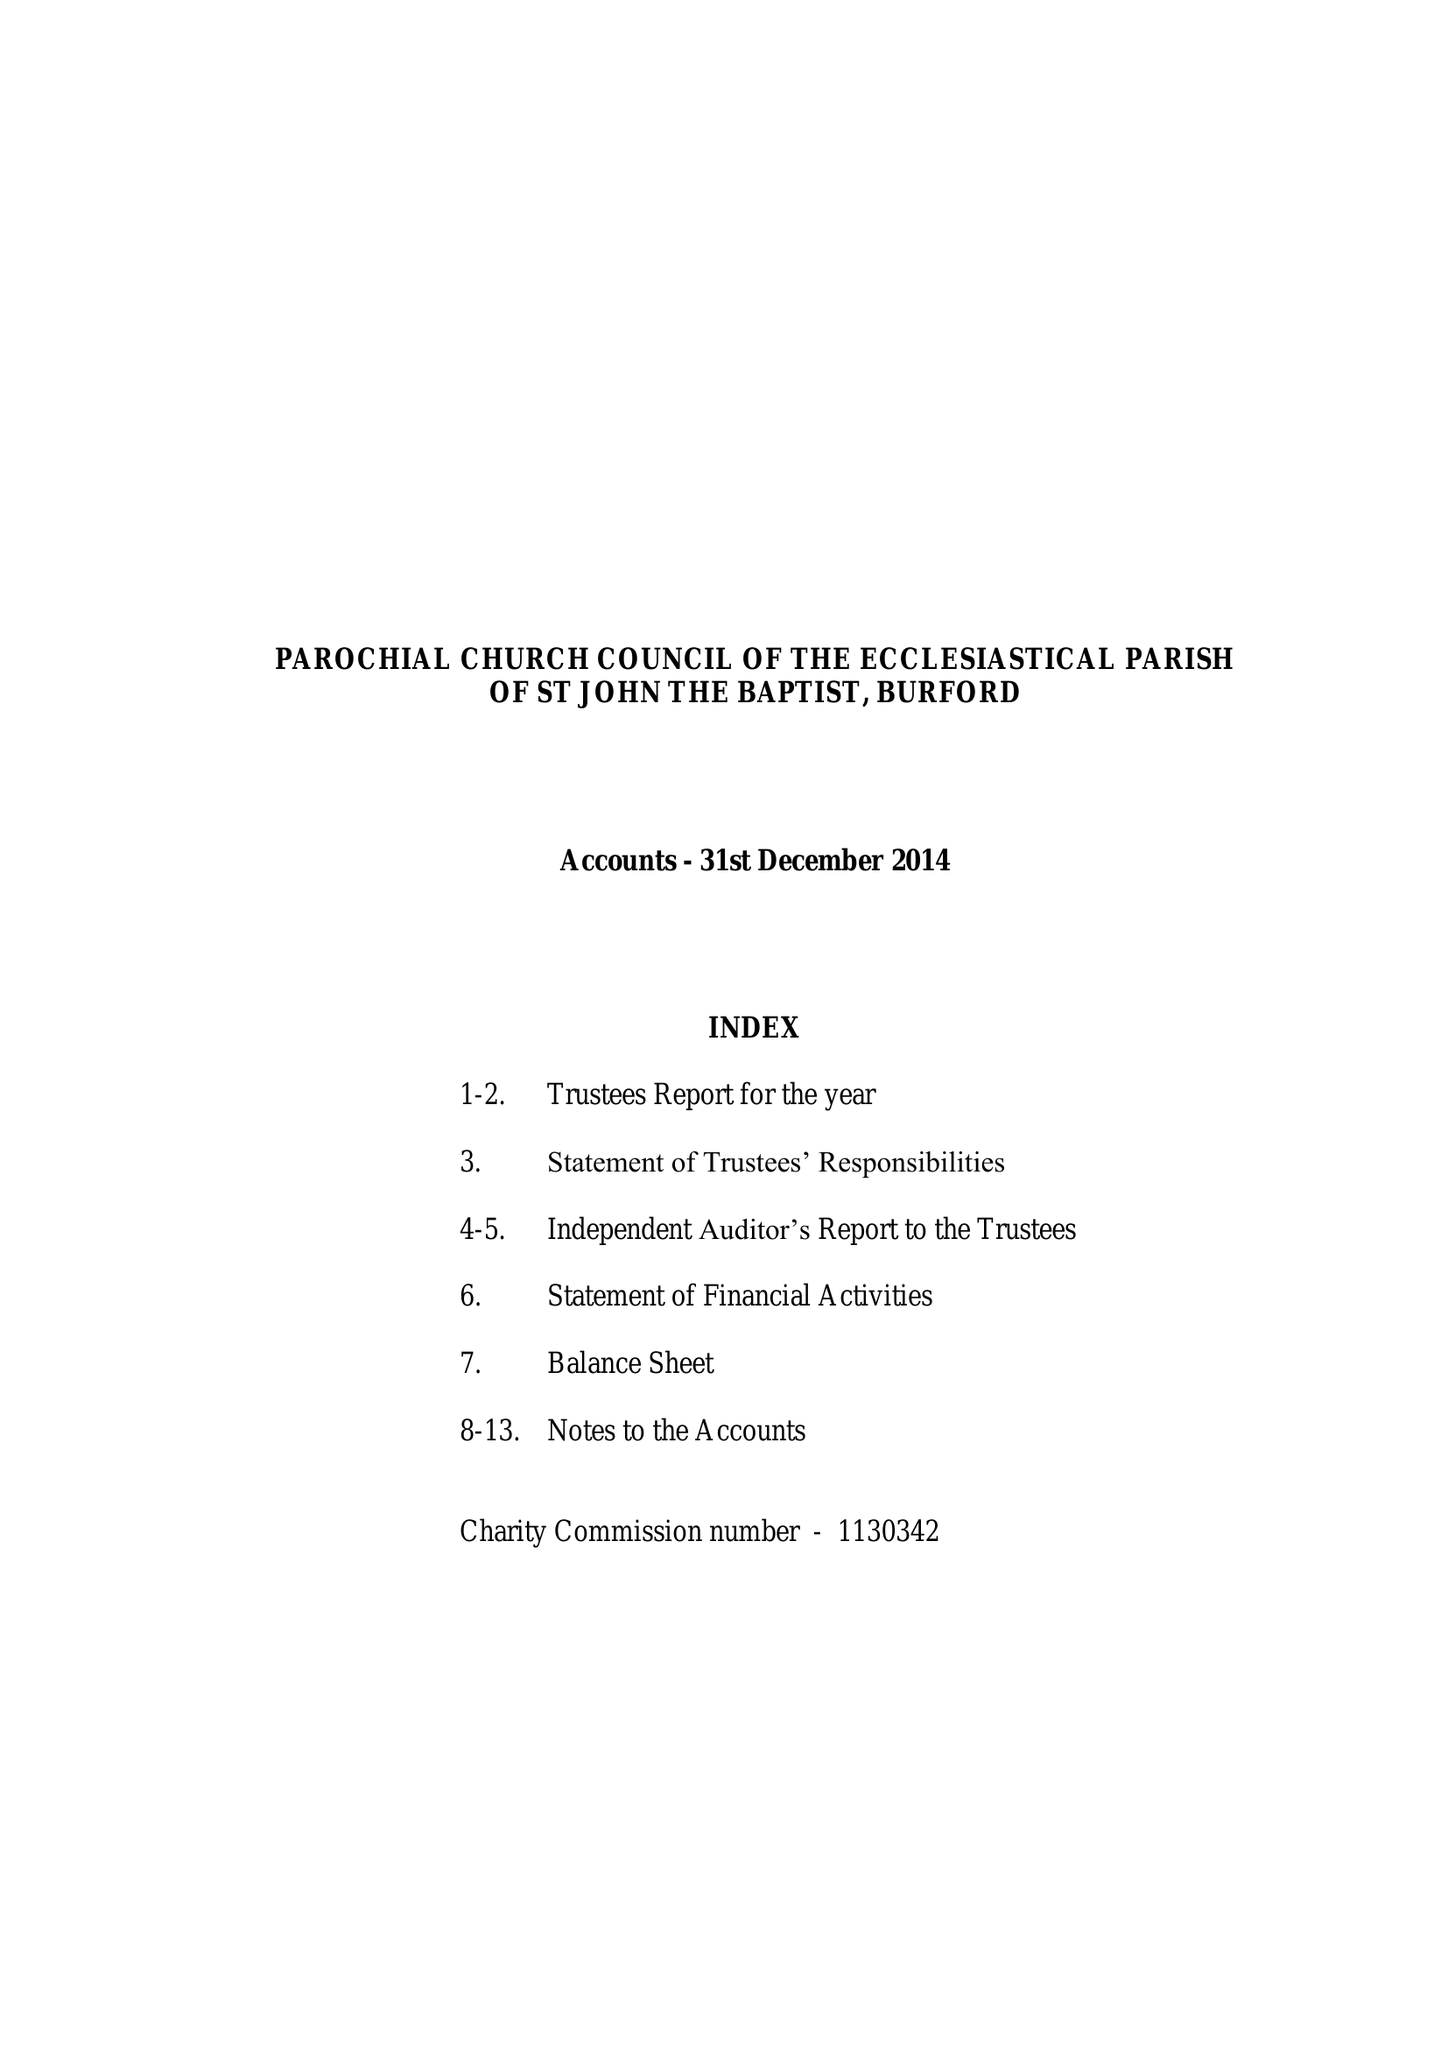What is the value for the charity_number?
Answer the question using a single word or phrase. 1130342 